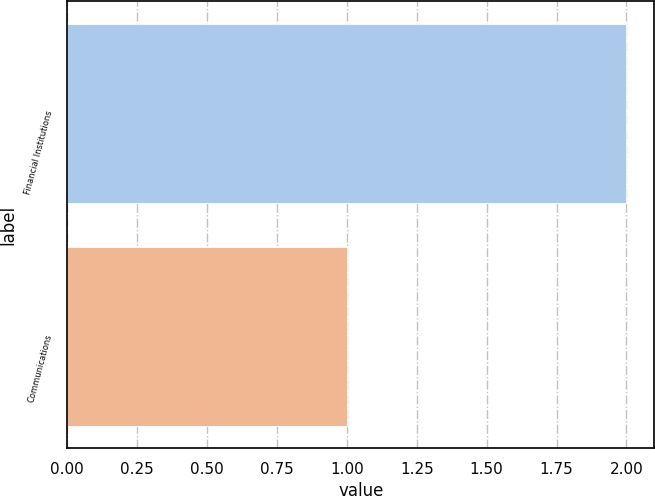Convert chart. <chart><loc_0><loc_0><loc_500><loc_500><bar_chart><fcel>Financial Institutions<fcel>Communications<nl><fcel>2<fcel>1<nl></chart> 